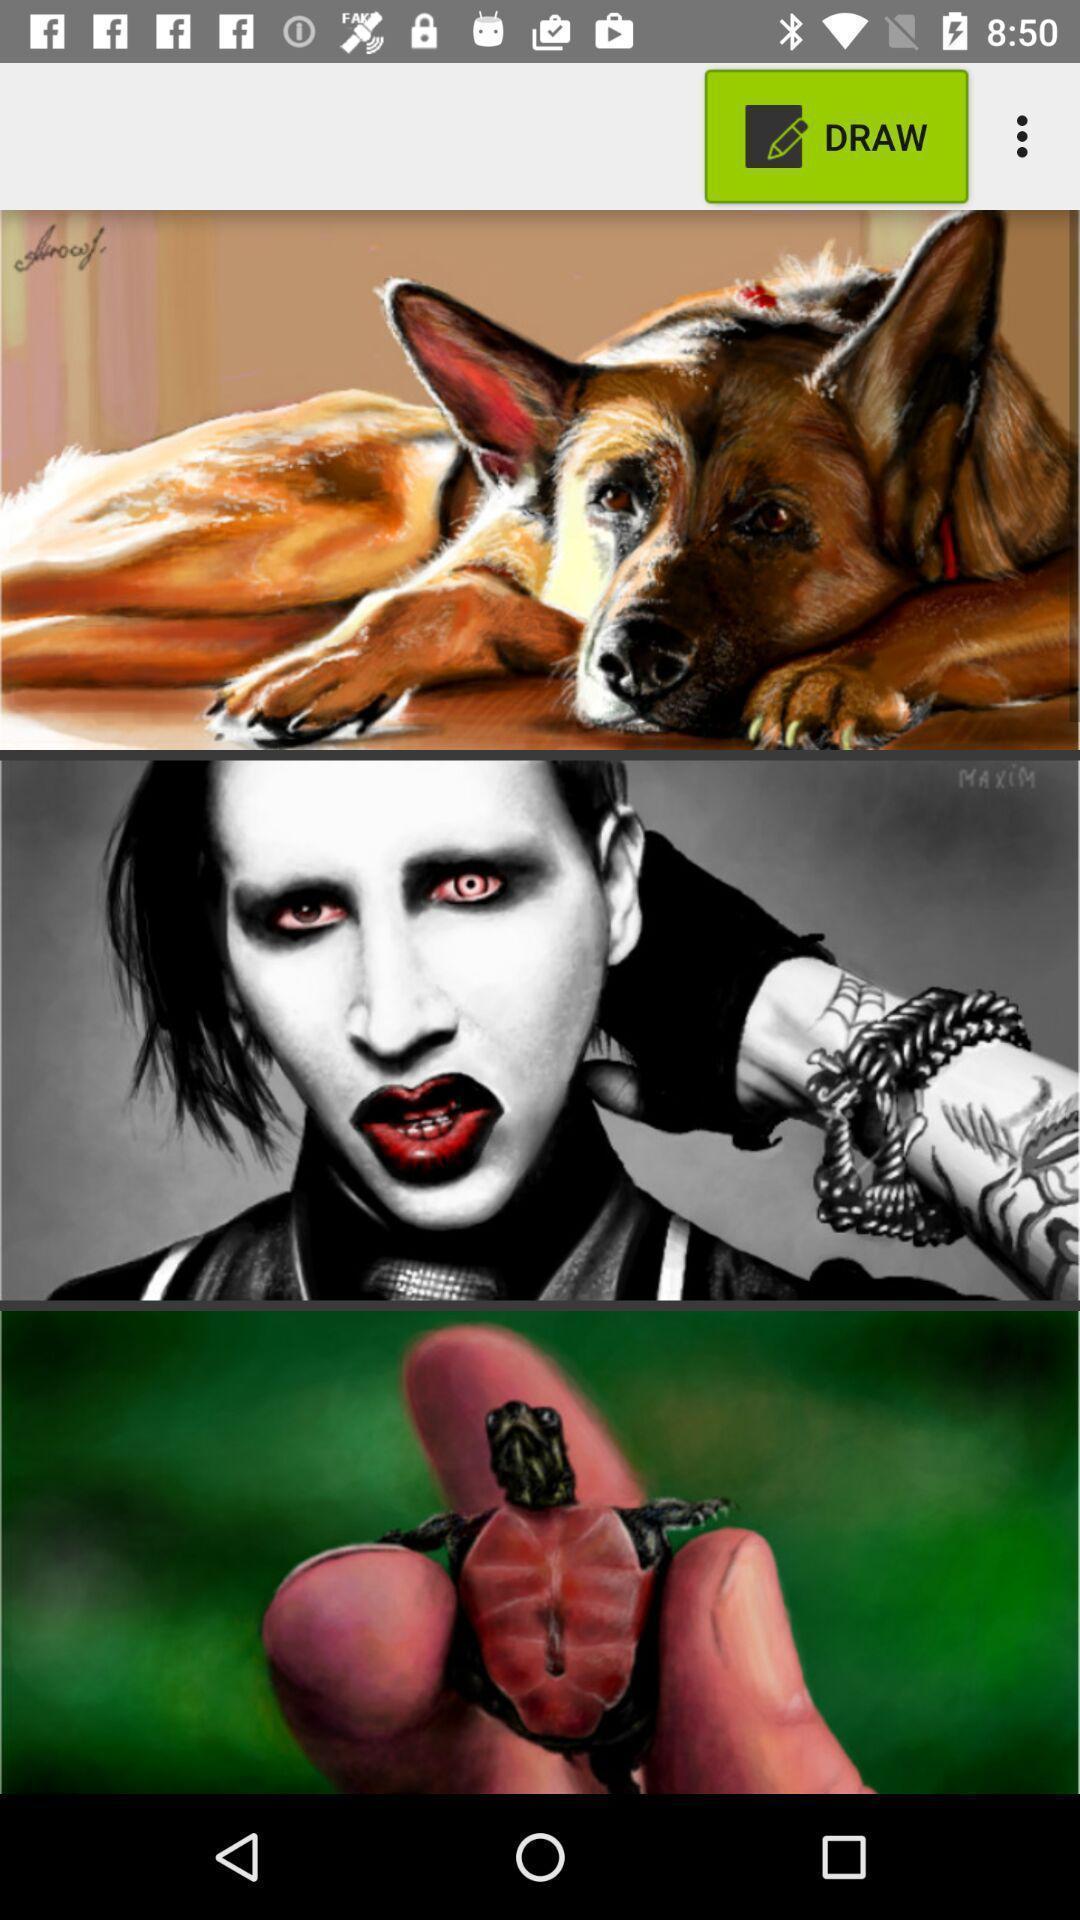Provide a textual representation of this image. Page showing different images to draw. 